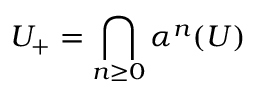<formula> <loc_0><loc_0><loc_500><loc_500>U _ { + } = \bigcap _ { n \geq 0 } \alpha ^ { n } ( U )</formula> 